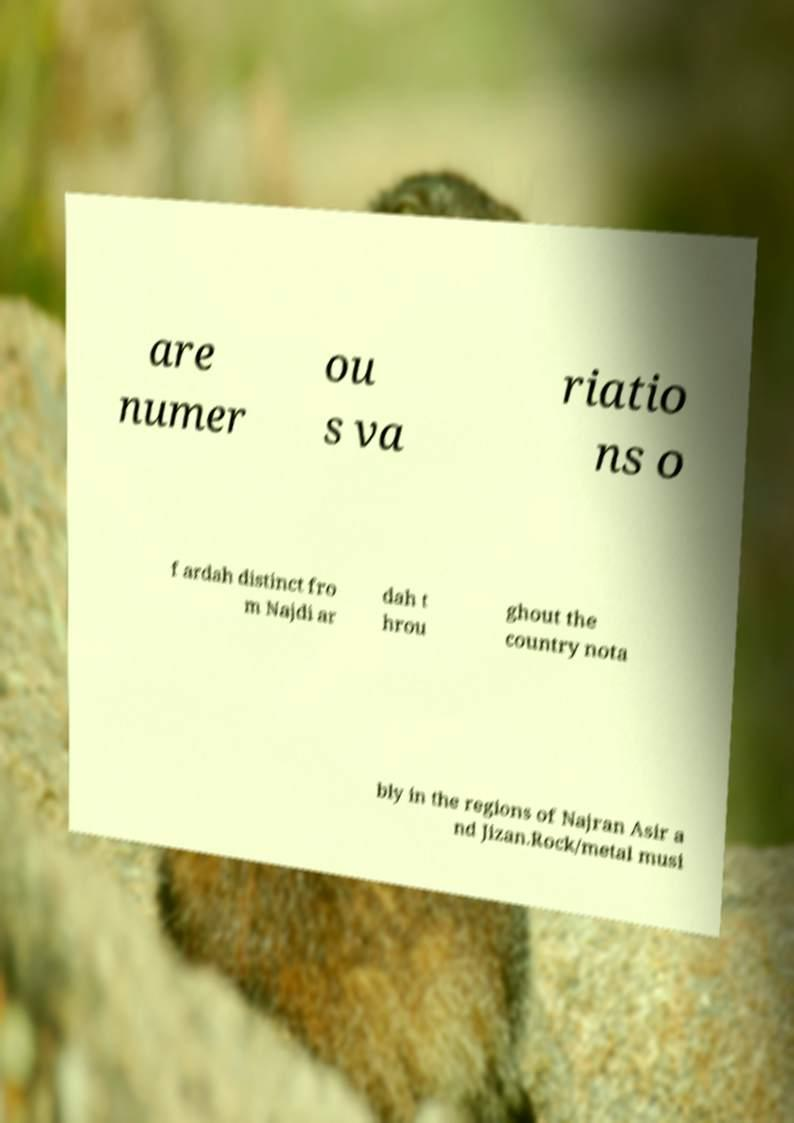Please identify and transcribe the text found in this image. are numer ou s va riatio ns o f ardah distinct fro m Najdi ar dah t hrou ghout the country nota bly in the regions of Najran Asir a nd Jizan.Rock/metal musi 